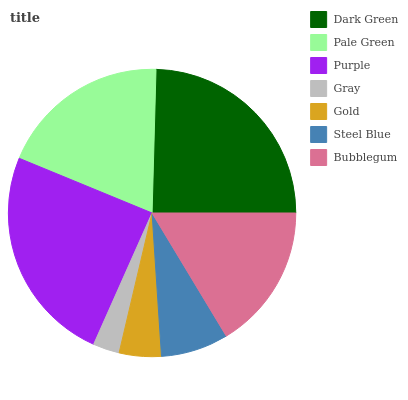Is Gray the minimum?
Answer yes or no. Yes. Is Dark Green the maximum?
Answer yes or no. Yes. Is Pale Green the minimum?
Answer yes or no. No. Is Pale Green the maximum?
Answer yes or no. No. Is Dark Green greater than Pale Green?
Answer yes or no. Yes. Is Pale Green less than Dark Green?
Answer yes or no. Yes. Is Pale Green greater than Dark Green?
Answer yes or no. No. Is Dark Green less than Pale Green?
Answer yes or no. No. Is Bubblegum the high median?
Answer yes or no. Yes. Is Bubblegum the low median?
Answer yes or no. Yes. Is Purple the high median?
Answer yes or no. No. Is Gray the low median?
Answer yes or no. No. 